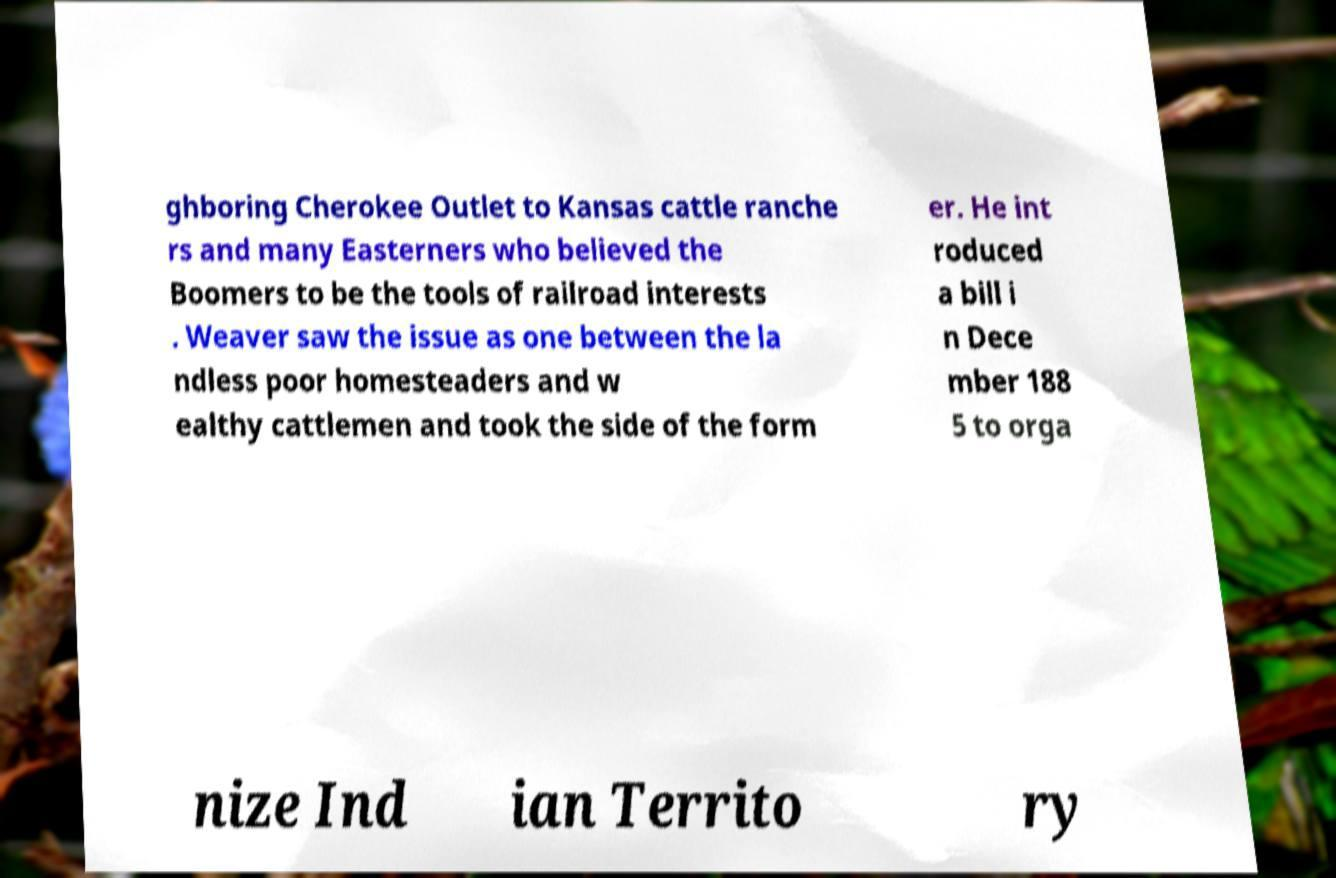What messages or text are displayed in this image? I need them in a readable, typed format. ghboring Cherokee Outlet to Kansas cattle ranche rs and many Easterners who believed the Boomers to be the tools of railroad interests . Weaver saw the issue as one between the la ndless poor homesteaders and w ealthy cattlemen and took the side of the form er. He int roduced a bill i n Dece mber 188 5 to orga nize Ind ian Territo ry 